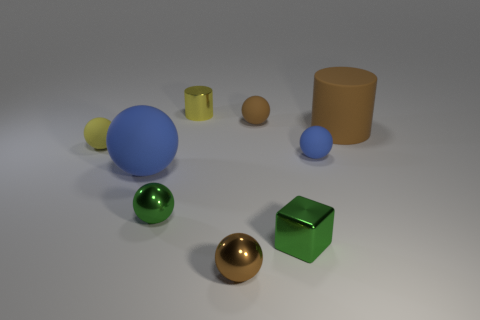Subtract all blue spheres. How many were subtracted if there are1blue spheres left? 1 Subtract all metallic spheres. How many spheres are left? 4 Subtract all cyan cubes. How many blue spheres are left? 2 Subtract 2 spheres. How many spheres are left? 4 Subtract all yellow balls. How many balls are left? 5 Add 1 tiny brown things. How many objects exist? 10 Subtract all spheres. How many objects are left? 3 Subtract all blue spheres. Subtract all green cylinders. How many spheres are left? 4 Subtract all blue matte spheres. Subtract all blue rubber objects. How many objects are left? 5 Add 2 tiny yellow shiny cylinders. How many tiny yellow shiny cylinders are left? 3 